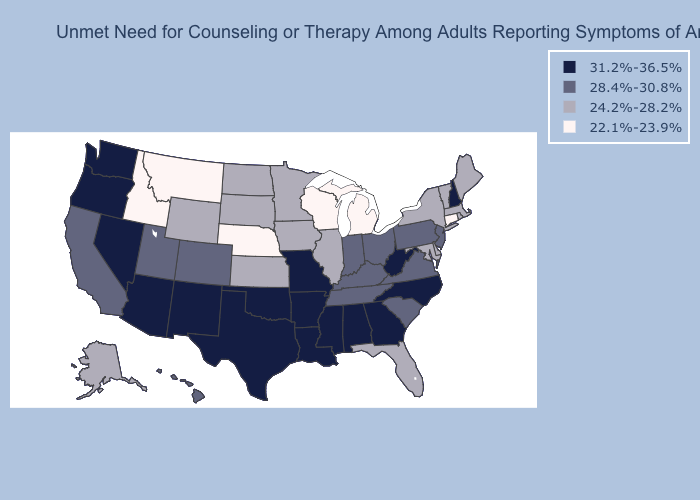Which states have the lowest value in the South?
Write a very short answer. Delaware, Florida, Maryland. Which states have the lowest value in the USA?
Quick response, please. Connecticut, Idaho, Michigan, Montana, Nebraska, Wisconsin. Name the states that have a value in the range 28.4%-30.8%?
Be succinct. California, Colorado, Hawaii, Indiana, Kentucky, New Jersey, Ohio, Pennsylvania, South Carolina, Tennessee, Utah, Virginia. Does Oklahoma have a higher value than Wisconsin?
Short answer required. Yes. Name the states that have a value in the range 22.1%-23.9%?
Answer briefly. Connecticut, Idaho, Michigan, Montana, Nebraska, Wisconsin. Does the map have missing data?
Keep it brief. No. Which states hav the highest value in the MidWest?
Write a very short answer. Missouri. Among the states that border Kentucky , does Indiana have the lowest value?
Answer briefly. No. Does Oklahoma have the highest value in the South?
Keep it brief. Yes. What is the highest value in the USA?
Keep it brief. 31.2%-36.5%. Does Nebraska have the lowest value in the USA?
Quick response, please. Yes. Which states have the highest value in the USA?
Quick response, please. Alabama, Arizona, Arkansas, Georgia, Louisiana, Mississippi, Missouri, Nevada, New Hampshire, New Mexico, North Carolina, Oklahoma, Oregon, Texas, Washington, West Virginia. Name the states that have a value in the range 22.1%-23.9%?
Quick response, please. Connecticut, Idaho, Michigan, Montana, Nebraska, Wisconsin. What is the lowest value in the USA?
Give a very brief answer. 22.1%-23.9%. Which states have the lowest value in the MidWest?
Short answer required. Michigan, Nebraska, Wisconsin. 